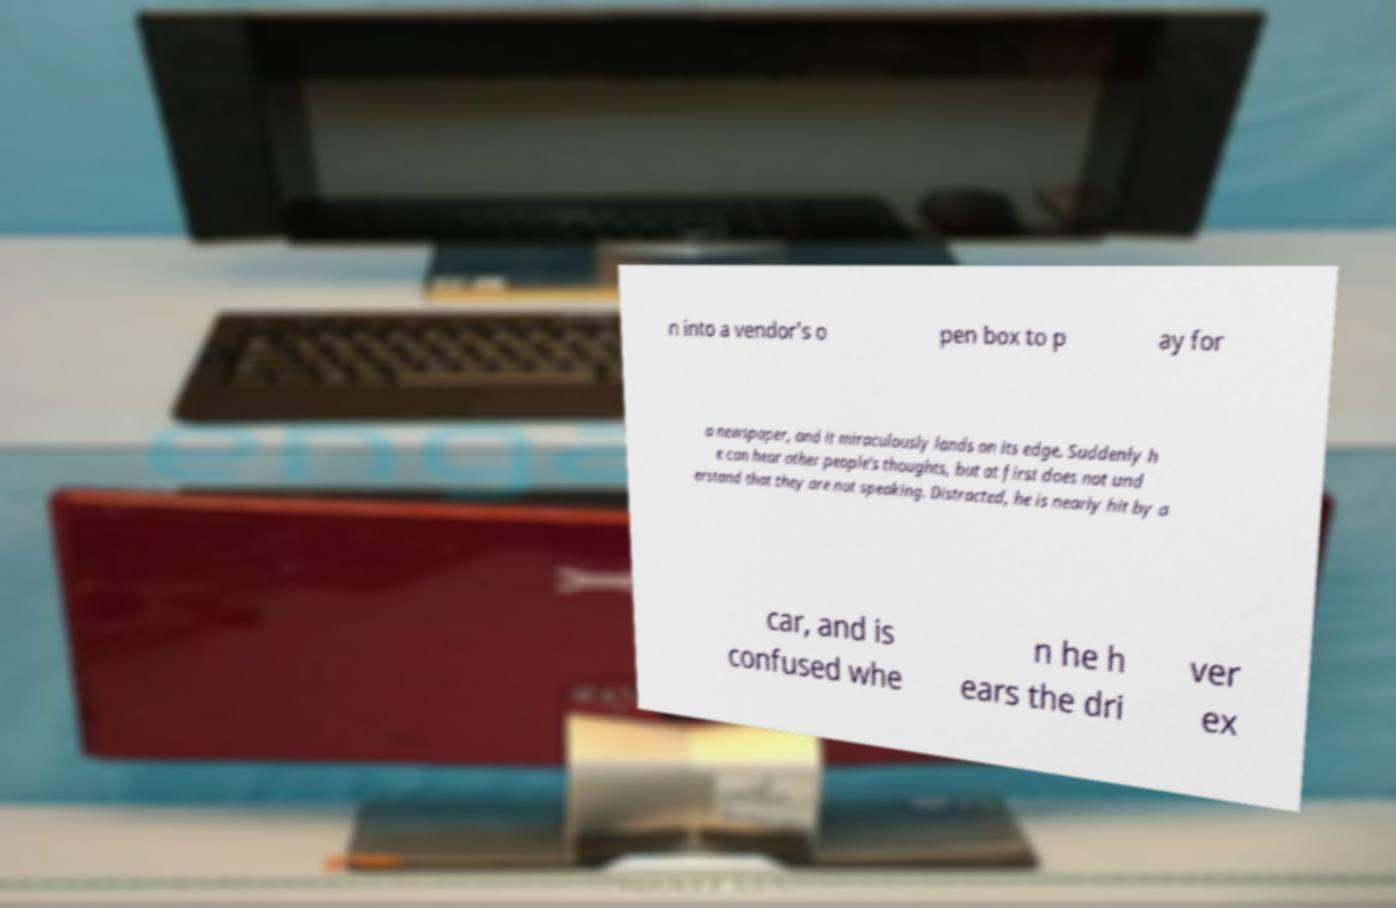Could you assist in decoding the text presented in this image and type it out clearly? n into a vendor's o pen box to p ay for a newspaper, and it miraculously lands on its edge. Suddenly h e can hear other people's thoughts, but at first does not und erstand that they are not speaking. Distracted, he is nearly hit by a car, and is confused whe n he h ears the dri ver ex 